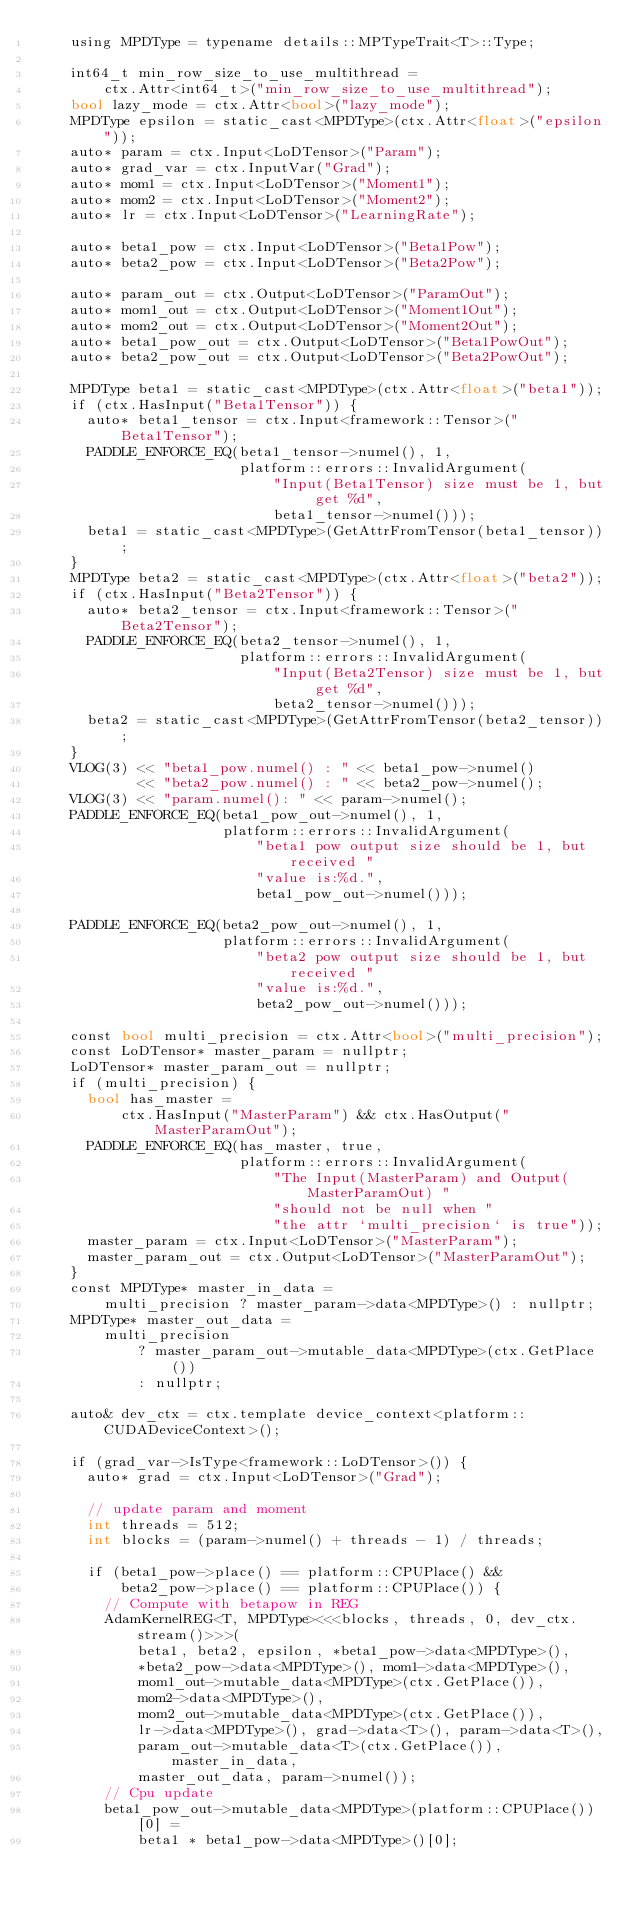<code> <loc_0><loc_0><loc_500><loc_500><_Cuda_>    using MPDType = typename details::MPTypeTrait<T>::Type;

    int64_t min_row_size_to_use_multithread =
        ctx.Attr<int64_t>("min_row_size_to_use_multithread");
    bool lazy_mode = ctx.Attr<bool>("lazy_mode");
    MPDType epsilon = static_cast<MPDType>(ctx.Attr<float>("epsilon"));
    auto* param = ctx.Input<LoDTensor>("Param");
    auto* grad_var = ctx.InputVar("Grad");
    auto* mom1 = ctx.Input<LoDTensor>("Moment1");
    auto* mom2 = ctx.Input<LoDTensor>("Moment2");
    auto* lr = ctx.Input<LoDTensor>("LearningRate");

    auto* beta1_pow = ctx.Input<LoDTensor>("Beta1Pow");
    auto* beta2_pow = ctx.Input<LoDTensor>("Beta2Pow");

    auto* param_out = ctx.Output<LoDTensor>("ParamOut");
    auto* mom1_out = ctx.Output<LoDTensor>("Moment1Out");
    auto* mom2_out = ctx.Output<LoDTensor>("Moment2Out");
    auto* beta1_pow_out = ctx.Output<LoDTensor>("Beta1PowOut");
    auto* beta2_pow_out = ctx.Output<LoDTensor>("Beta2PowOut");

    MPDType beta1 = static_cast<MPDType>(ctx.Attr<float>("beta1"));
    if (ctx.HasInput("Beta1Tensor")) {
      auto* beta1_tensor = ctx.Input<framework::Tensor>("Beta1Tensor");
      PADDLE_ENFORCE_EQ(beta1_tensor->numel(), 1,
                        platform::errors::InvalidArgument(
                            "Input(Beta1Tensor) size must be 1, but get %d",
                            beta1_tensor->numel()));
      beta1 = static_cast<MPDType>(GetAttrFromTensor(beta1_tensor));
    }
    MPDType beta2 = static_cast<MPDType>(ctx.Attr<float>("beta2"));
    if (ctx.HasInput("Beta2Tensor")) {
      auto* beta2_tensor = ctx.Input<framework::Tensor>("Beta2Tensor");
      PADDLE_ENFORCE_EQ(beta2_tensor->numel(), 1,
                        platform::errors::InvalidArgument(
                            "Input(Beta2Tensor) size must be 1, but get %d",
                            beta2_tensor->numel()));
      beta2 = static_cast<MPDType>(GetAttrFromTensor(beta2_tensor));
    }
    VLOG(3) << "beta1_pow.numel() : " << beta1_pow->numel()
            << "beta2_pow.numel() : " << beta2_pow->numel();
    VLOG(3) << "param.numel(): " << param->numel();
    PADDLE_ENFORCE_EQ(beta1_pow_out->numel(), 1,
                      platform::errors::InvalidArgument(
                          "beta1 pow output size should be 1, but received "
                          "value is:%d.",
                          beta1_pow_out->numel()));

    PADDLE_ENFORCE_EQ(beta2_pow_out->numel(), 1,
                      platform::errors::InvalidArgument(
                          "beta2 pow output size should be 1, but received "
                          "value is:%d.",
                          beta2_pow_out->numel()));

    const bool multi_precision = ctx.Attr<bool>("multi_precision");
    const LoDTensor* master_param = nullptr;
    LoDTensor* master_param_out = nullptr;
    if (multi_precision) {
      bool has_master =
          ctx.HasInput("MasterParam") && ctx.HasOutput("MasterParamOut");
      PADDLE_ENFORCE_EQ(has_master, true,
                        platform::errors::InvalidArgument(
                            "The Input(MasterParam) and Output(MasterParamOut) "
                            "should not be null when "
                            "the attr `multi_precision` is true"));
      master_param = ctx.Input<LoDTensor>("MasterParam");
      master_param_out = ctx.Output<LoDTensor>("MasterParamOut");
    }
    const MPDType* master_in_data =
        multi_precision ? master_param->data<MPDType>() : nullptr;
    MPDType* master_out_data =
        multi_precision
            ? master_param_out->mutable_data<MPDType>(ctx.GetPlace())
            : nullptr;

    auto& dev_ctx = ctx.template device_context<platform::CUDADeviceContext>();

    if (grad_var->IsType<framework::LoDTensor>()) {
      auto* grad = ctx.Input<LoDTensor>("Grad");

      // update param and moment
      int threads = 512;
      int blocks = (param->numel() + threads - 1) / threads;

      if (beta1_pow->place() == platform::CPUPlace() &&
          beta2_pow->place() == platform::CPUPlace()) {
        // Compute with betapow in REG
        AdamKernelREG<T, MPDType><<<blocks, threads, 0, dev_ctx.stream()>>>(
            beta1, beta2, epsilon, *beta1_pow->data<MPDType>(),
            *beta2_pow->data<MPDType>(), mom1->data<MPDType>(),
            mom1_out->mutable_data<MPDType>(ctx.GetPlace()),
            mom2->data<MPDType>(),
            mom2_out->mutable_data<MPDType>(ctx.GetPlace()),
            lr->data<MPDType>(), grad->data<T>(), param->data<T>(),
            param_out->mutable_data<T>(ctx.GetPlace()), master_in_data,
            master_out_data, param->numel());
        // Cpu update
        beta1_pow_out->mutable_data<MPDType>(platform::CPUPlace())[0] =
            beta1 * beta1_pow->data<MPDType>()[0];</code> 